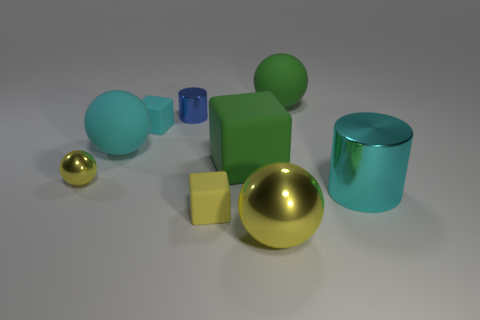Subtract all gray cylinders. How many yellow balls are left? 2 Subtract all green balls. How many balls are left? 3 Subtract all cyan spheres. How many spheres are left? 3 Add 9 cyan balls. How many cyan balls exist? 10 Subtract 1 blue cylinders. How many objects are left? 8 Subtract all blocks. How many objects are left? 6 Subtract all purple cubes. Subtract all red cylinders. How many cubes are left? 3 Subtract all large green matte things. Subtract all big metal cylinders. How many objects are left? 6 Add 3 matte spheres. How many matte spheres are left? 5 